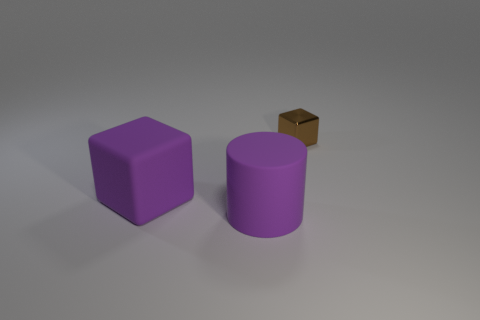Add 1 metal things. How many objects exist? 4 Subtract 1 cubes. How many cubes are left? 1 Subtract all cylinders. How many objects are left? 2 Add 3 matte objects. How many matte objects are left? 5 Add 1 small brown shiny blocks. How many small brown shiny blocks exist? 2 Subtract 1 purple cylinders. How many objects are left? 2 Subtract all green cubes. Subtract all yellow balls. How many cubes are left? 2 Subtract all small gray metallic spheres. Subtract all purple rubber things. How many objects are left? 1 